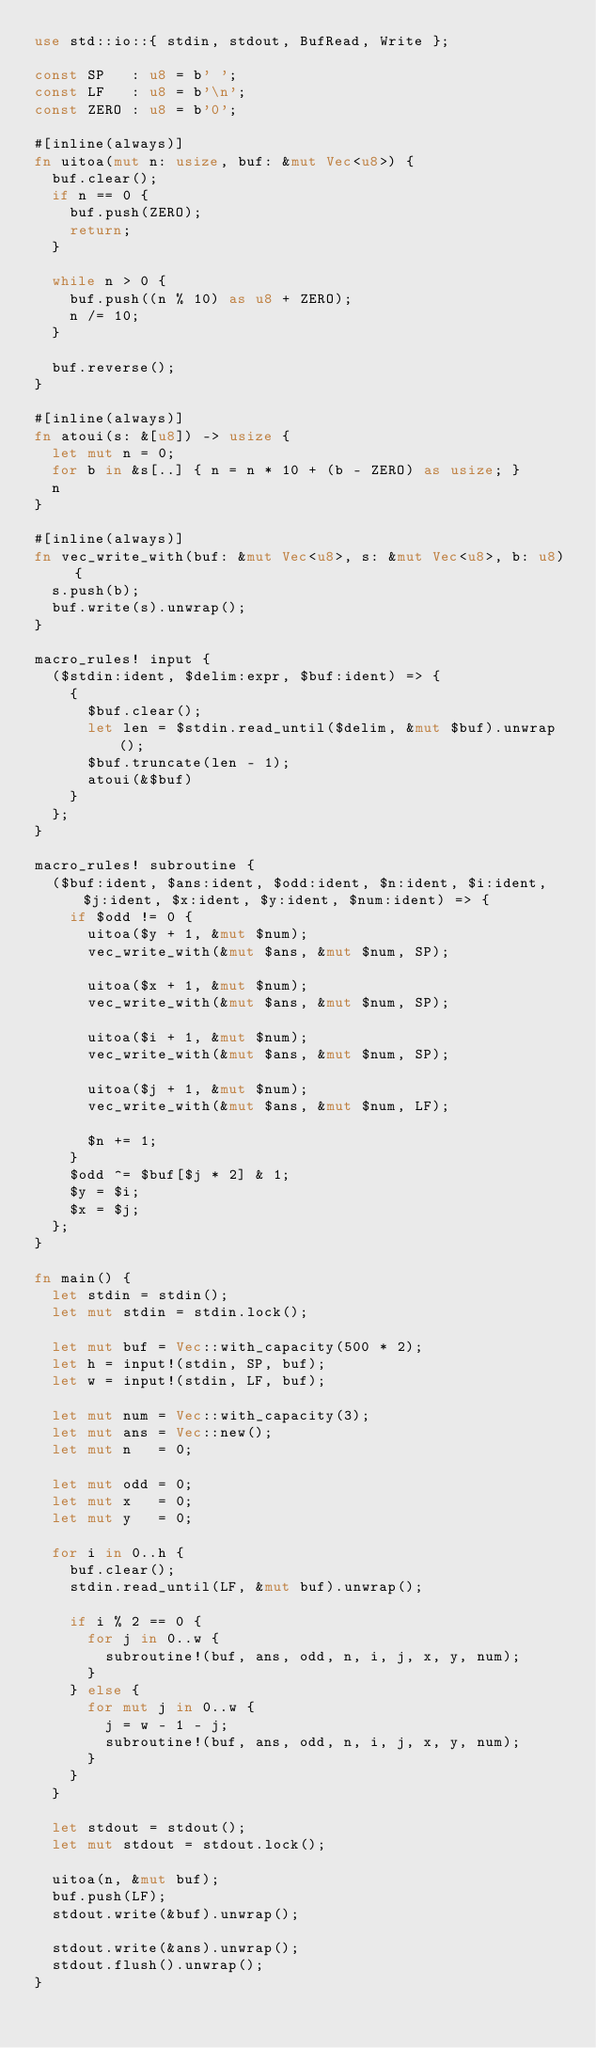Convert code to text. <code><loc_0><loc_0><loc_500><loc_500><_Rust_>use std::io::{ stdin, stdout, BufRead, Write };

const SP   : u8 = b' ';
const LF   : u8 = b'\n';
const ZERO : u8 = b'0';

#[inline(always)]
fn uitoa(mut n: usize, buf: &mut Vec<u8>) {
  buf.clear();
  if n == 0 {
    buf.push(ZERO);
    return;
  }

  while n > 0 {
    buf.push((n % 10) as u8 + ZERO);
    n /= 10;
  }

  buf.reverse();
}

#[inline(always)]
fn atoui(s: &[u8]) -> usize {
  let mut n = 0;
  for b in &s[..] { n = n * 10 + (b - ZERO) as usize; }
  n
}

#[inline(always)]
fn vec_write_with(buf: &mut Vec<u8>, s: &mut Vec<u8>, b: u8) {
  s.push(b);
  buf.write(s).unwrap();
}

macro_rules! input {
  ($stdin:ident, $delim:expr, $buf:ident) => {
    {
      $buf.clear();
      let len = $stdin.read_until($delim, &mut $buf).unwrap();
      $buf.truncate(len - 1);
      atoui(&$buf)
    }
  };
}

macro_rules! subroutine {
  ($buf:ident, $ans:ident, $odd:ident, $n:ident, $i:ident, $j:ident, $x:ident, $y:ident, $num:ident) => {
    if $odd != 0 {
      uitoa($y + 1, &mut $num);
      vec_write_with(&mut $ans, &mut $num, SP);

      uitoa($x + 1, &mut $num);
      vec_write_with(&mut $ans, &mut $num, SP);

      uitoa($i + 1, &mut $num);
      vec_write_with(&mut $ans, &mut $num, SP);

      uitoa($j + 1, &mut $num);
      vec_write_with(&mut $ans, &mut $num, LF);

      $n += 1;
    }
    $odd ^= $buf[$j * 2] & 1;
    $y = $i;
    $x = $j;
  };
}

fn main() {
  let stdin = stdin();
  let mut stdin = stdin.lock();

  let mut buf = Vec::with_capacity(500 * 2);
  let h = input!(stdin, SP, buf);
  let w = input!(stdin, LF, buf);

  let mut num = Vec::with_capacity(3);
  let mut ans = Vec::new();
  let mut n   = 0;

  let mut odd = 0;
  let mut x   = 0;
  let mut y   = 0;

  for i in 0..h {
    buf.clear();
    stdin.read_until(LF, &mut buf).unwrap();

    if i % 2 == 0 {
      for j in 0..w {
        subroutine!(buf, ans, odd, n, i, j, x, y, num);
      }
    } else {
      for mut j in 0..w {
        j = w - 1 - j;
        subroutine!(buf, ans, odd, n, i, j, x, y, num);
      }
    }
  }

  let stdout = stdout();
  let mut stdout = stdout.lock();

  uitoa(n, &mut buf);
  buf.push(LF);
  stdout.write(&buf).unwrap();

  stdout.write(&ans).unwrap();
  stdout.flush().unwrap();
}
</code> 